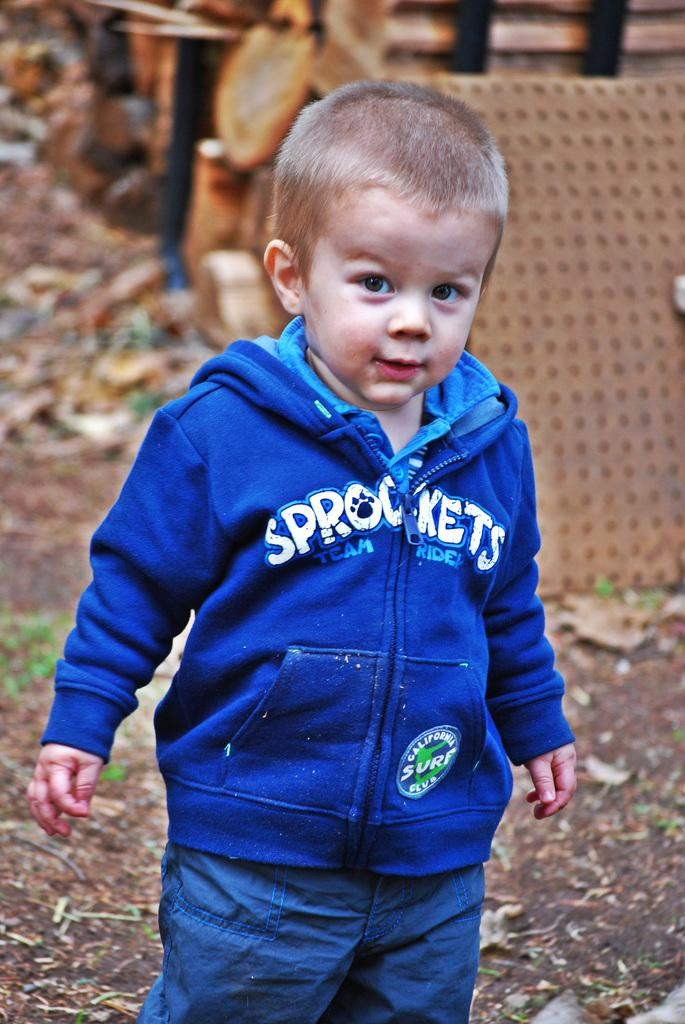<image>
Give a short and clear explanation of the subsequent image. a person with the word sprockets on their jacket 